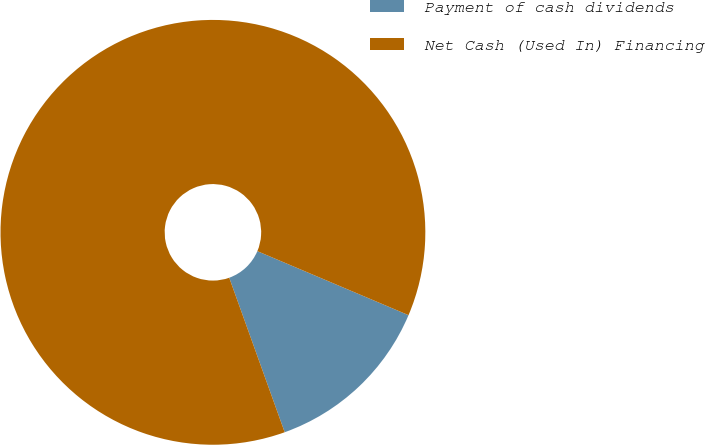<chart> <loc_0><loc_0><loc_500><loc_500><pie_chart><fcel>Payment of cash dividends<fcel>Net Cash (Used In) Financing<nl><fcel>13.14%<fcel>86.86%<nl></chart> 